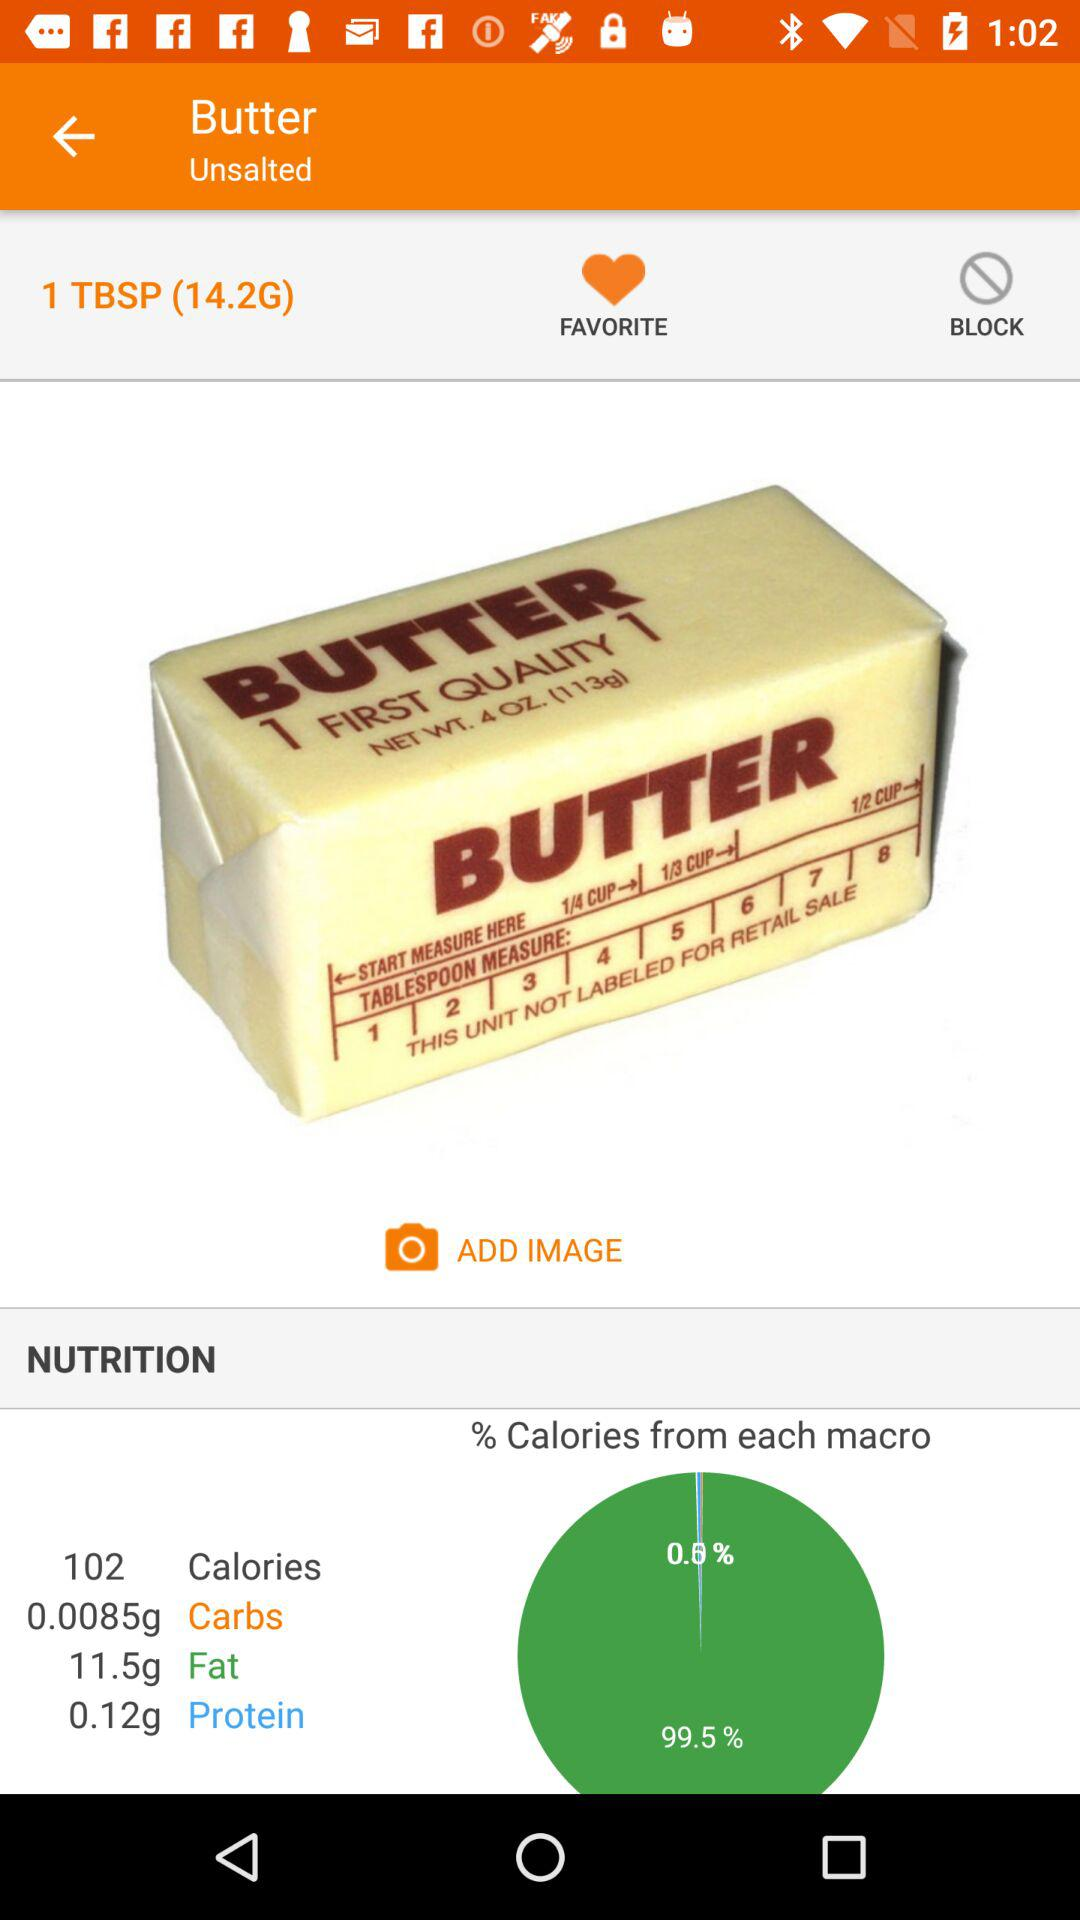What is the weight of 1 TBSP of butter? The weight of 1 TBSP of butter is 14.2 grams. 